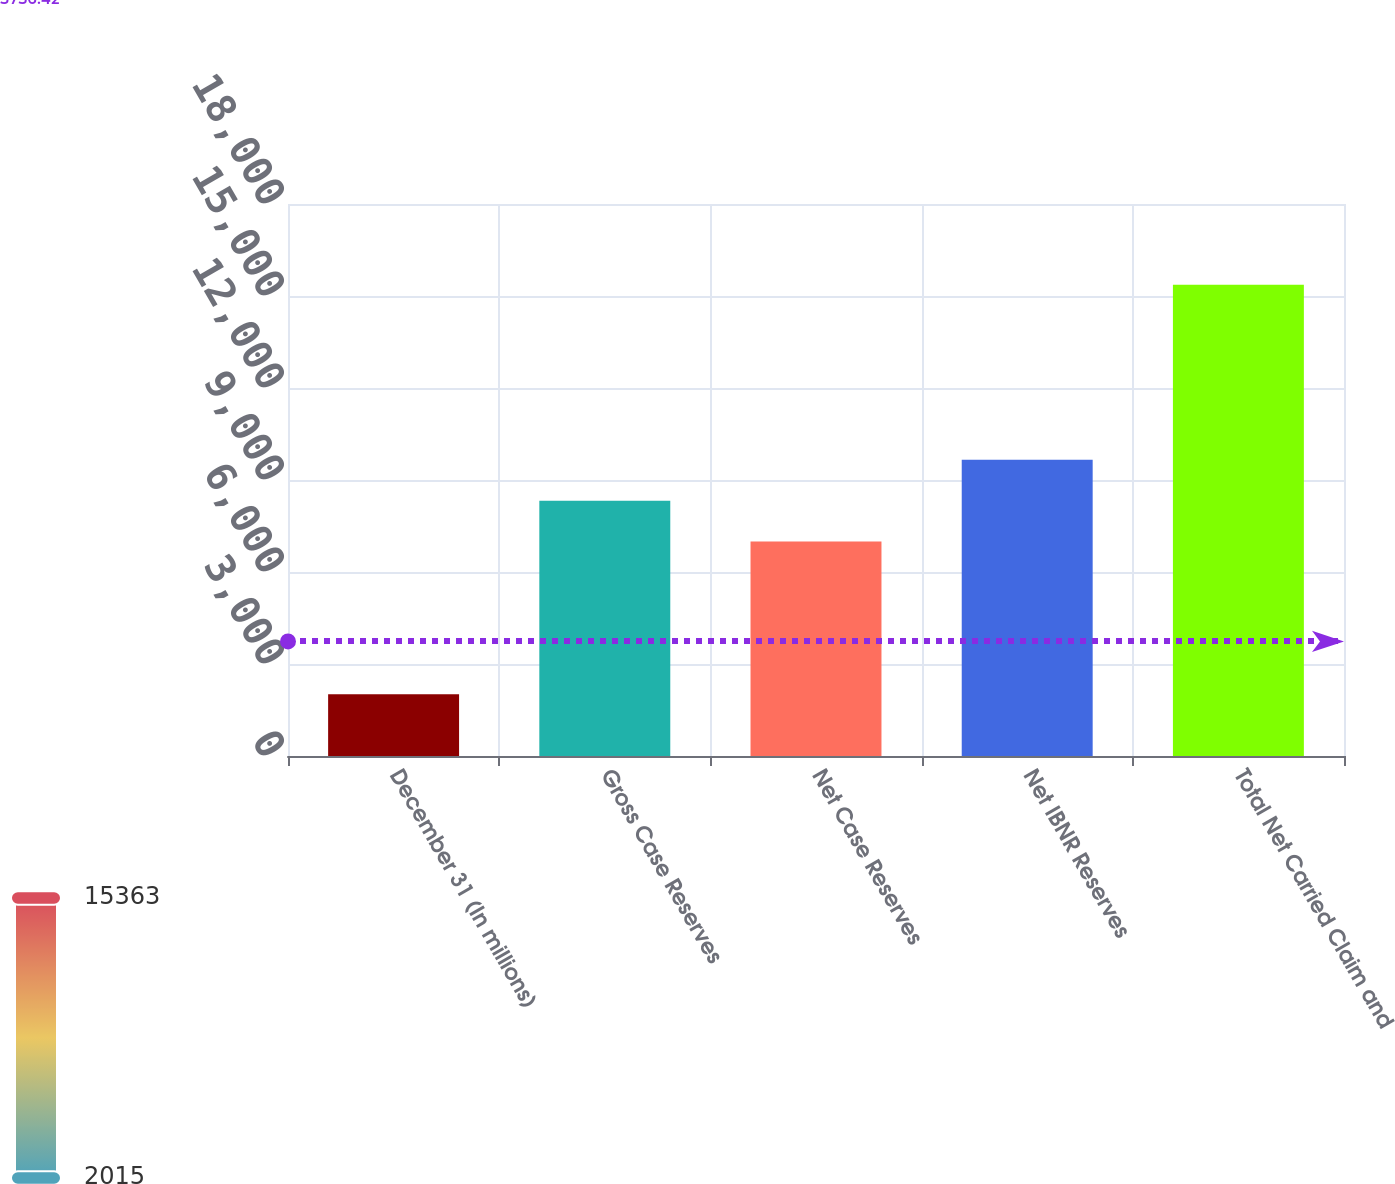Convert chart. <chart><loc_0><loc_0><loc_500><loc_500><bar_chart><fcel>December 31 (In millions)<fcel>Gross Case Reserves<fcel>Net Case Reserves<fcel>Net IBNR Reserves<fcel>Total Net Carried Claim and<nl><fcel>2015<fcel>8326.8<fcel>6992<fcel>9661.6<fcel>15363<nl></chart> 